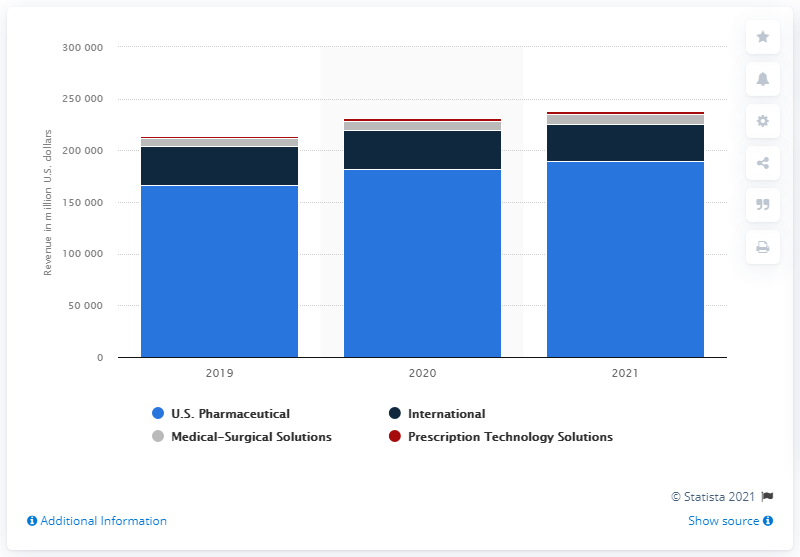Mention a couple of crucial points in this snapshot. In the fiscal year 2021, the total revenue generated in the medical-surgical solutions segment was 10,099. 